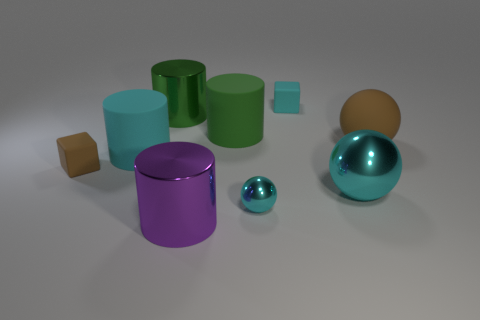Subtract all cyan spheres. How many spheres are left? 1 Subtract all purple cylinders. How many cylinders are left? 3 Subtract all cylinders. How many objects are left? 5 Subtract all red spheres. How many cyan cubes are left? 1 Subtract 0 yellow cylinders. How many objects are left? 9 Subtract 1 cylinders. How many cylinders are left? 3 Subtract all brown spheres. Subtract all brown cylinders. How many spheres are left? 2 Subtract all brown spheres. Subtract all big green metallic objects. How many objects are left? 7 Add 1 big purple metallic cylinders. How many big purple metallic cylinders are left? 2 Add 1 big yellow rubber balls. How many big yellow rubber balls exist? 1 